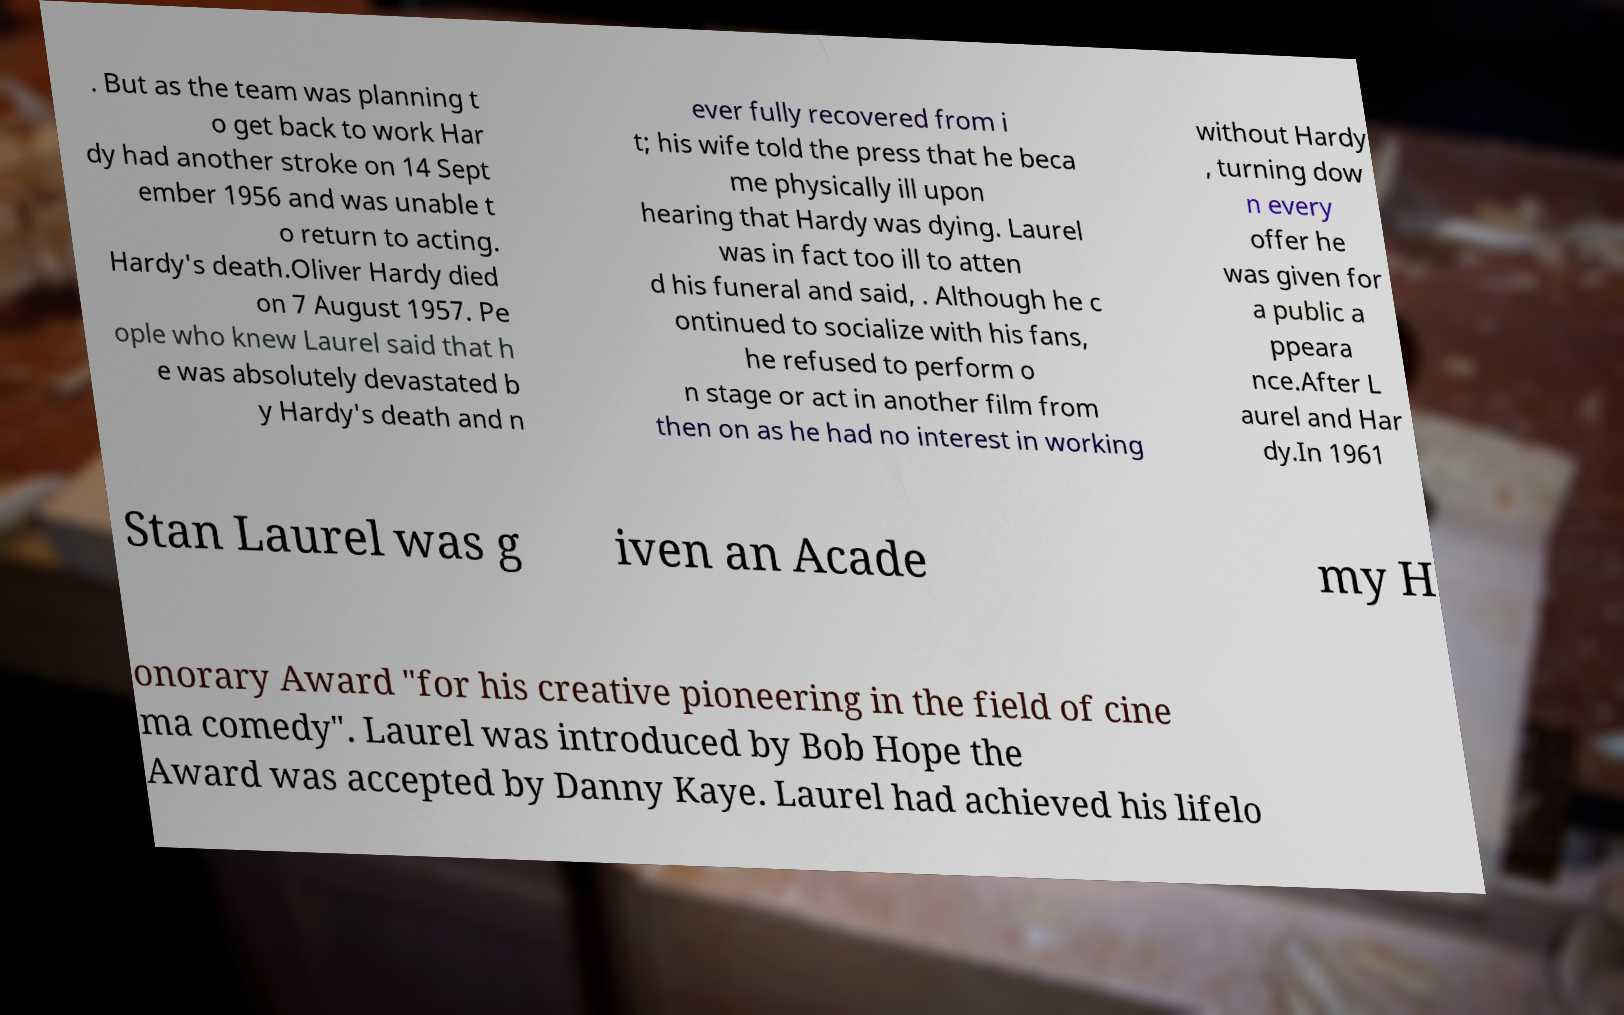Can you read and provide the text displayed in the image?This photo seems to have some interesting text. Can you extract and type it out for me? . But as the team was planning t o get back to work Har dy had another stroke on 14 Sept ember 1956 and was unable t o return to acting. Hardy's death.Oliver Hardy died on 7 August 1957. Pe ople who knew Laurel said that h e was absolutely devastated b y Hardy's death and n ever fully recovered from i t; his wife told the press that he beca me physically ill upon hearing that Hardy was dying. Laurel was in fact too ill to atten d his funeral and said, . Although he c ontinued to socialize with his fans, he refused to perform o n stage or act in another film from then on as he had no interest in working without Hardy , turning dow n every offer he was given for a public a ppeara nce.After L aurel and Har dy.In 1961 Stan Laurel was g iven an Acade my H onorary Award "for his creative pioneering in the field of cine ma comedy". Laurel was introduced by Bob Hope the Award was accepted by Danny Kaye. Laurel had achieved his lifelo 